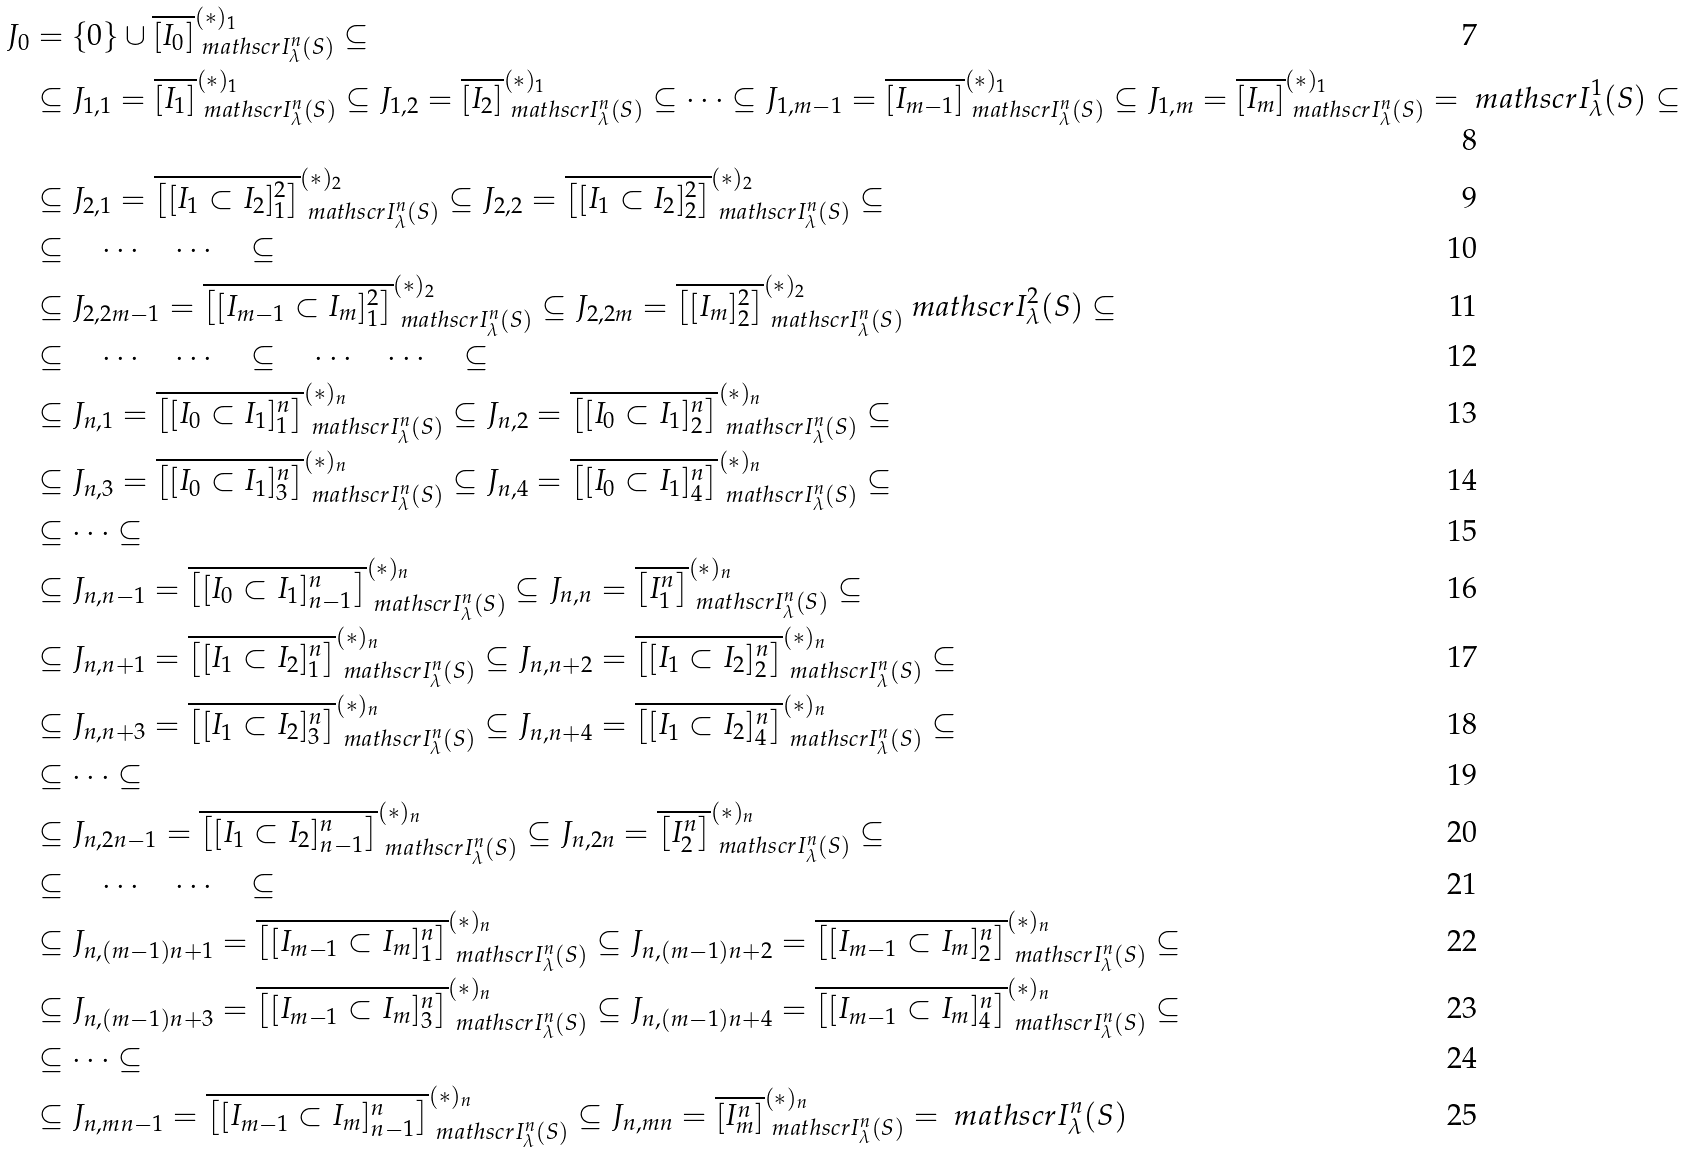<formula> <loc_0><loc_0><loc_500><loc_500>J _ { 0 } & = \{ 0 \} \cup \overline { [ I _ { 0 } ] } ^ { ( \ast ) _ { 1 } } _ { \ m a t h s c r { I } _ { \lambda } ^ { n } ( S ) } \subseteq \\ & \subseteq J _ { 1 , 1 } = \overline { [ I _ { 1 } ] } ^ { ( \ast ) _ { 1 } } _ { \ m a t h s c r { I } _ { \lambda } ^ { n } ( S ) } \subseteq J _ { 1 , 2 } = \overline { [ I _ { 2 } ] } ^ { ( \ast ) _ { 1 } } _ { \ m a t h s c r { I } _ { \lambda } ^ { n } ( S ) } \subseteq \cdots \subseteq J _ { 1 , m - 1 } = \overline { [ I _ { m - 1 } ] } ^ { ( \ast ) _ { 1 } } _ { \ m a t h s c r { I } _ { \lambda } ^ { n } ( S ) } \subseteq J _ { 1 , m } = \overline { [ I _ { m } ] } ^ { ( \ast ) _ { 1 } } _ { \ m a t h s c r { I } _ { \lambda } ^ { n } ( S ) } = \ m a t h s c r { I } _ { \lambda } ^ { 1 } ( S ) \subseteq \\ & \subseteq J _ { 2 , 1 } = \overline { \left [ [ I _ { 1 } \subset I _ { 2 } ] ^ { 2 } _ { 1 } \right ] } ^ { ( \ast ) _ { 2 } } _ { \ m a t h s c r { I } _ { \lambda } ^ { n } ( S ) } \subseteq J _ { 2 , 2 } = \overline { \left [ [ I _ { 1 } \subset I _ { 2 } ] ^ { 2 } _ { 2 } \right ] } ^ { ( \ast ) _ { 2 } } _ { \ m a t h s c r { I } _ { \lambda } ^ { n } ( S ) } \subseteq \\ & \subseteq \quad \cdots \quad \cdots \quad \subseteq \\ & \subseteq J _ { 2 , 2 m - 1 } = \overline { \left [ [ I _ { m - 1 } \subset I _ { m } ] ^ { 2 } _ { 1 } \right ] } ^ { ( \ast ) _ { 2 } } _ { \ m a t h s c r { I } _ { \lambda } ^ { n } ( S ) } \subseteq J _ { 2 , 2 m } = \overline { \left [ [ I _ { m } ] ^ { 2 } _ { 2 } \right ] } ^ { ( \ast ) _ { 2 } } _ { \ m a t h s c r { I } _ { \lambda } ^ { n } ( S ) } \ m a t h s c r { I } _ { \lambda } ^ { 2 } ( S ) \subseteq \\ & \subseteq \quad \cdots \quad \cdots \quad \subseteq \quad \cdots \quad \cdots \quad \subseteq \\ & \subseteq J _ { n , 1 } = \overline { \left [ [ I _ { 0 } \subset I _ { 1 } ] ^ { n } _ { 1 } \right ] } ^ { ( \ast ) _ { n } } _ { \ m a t h s c r { I } _ { \lambda } ^ { n } ( S ) } \subseteq J _ { n , 2 } = \overline { \left [ [ I _ { 0 } \subset I _ { 1 } ] ^ { n } _ { 2 } \right ] } ^ { ( \ast ) _ { n } } _ { \ m a t h s c r { I } _ { \lambda } ^ { n } ( S ) } \subseteq \\ & \subseteq J _ { n , 3 } = \overline { \left [ [ I _ { 0 } \subset I _ { 1 } ] ^ { n } _ { 3 } \right ] } ^ { ( \ast ) _ { n } } _ { \ m a t h s c r { I } _ { \lambda } ^ { n } ( S ) } \subseteq J _ { n , 4 } = \overline { \left [ [ I _ { 0 } \subset I _ { 1 } ] ^ { n } _ { 4 } \right ] } ^ { ( \ast ) _ { n } } _ { \ m a t h s c r { I } _ { \lambda } ^ { n } ( S ) } \subseteq \\ & \subseteq \cdots \subseteq \\ & \subseteq J _ { n , n - 1 } = \overline { \left [ [ I _ { 0 } \subset I _ { 1 } ] ^ { n } _ { n - 1 } \right ] } ^ { ( \ast ) _ { n } } _ { \ m a t h s c r { I } _ { \lambda } ^ { n } ( S ) } \subseteq J _ { n , n } = \overline { \left [ I _ { 1 } ^ { n } \right ] } ^ { ( \ast ) _ { n } } _ { \ m a t h s c r { I } _ { \lambda } ^ { n } ( S ) } \subseteq \\ & \subseteq J _ { n , n + 1 } = \overline { \left [ [ I _ { 1 } \subset I _ { 2 } ] ^ { n } _ { 1 } \right ] } ^ { ( \ast ) _ { n } } _ { \ m a t h s c r { I } _ { \lambda } ^ { n } ( S ) } \subseteq J _ { n , n + 2 } = \overline { \left [ [ I _ { 1 } \subset I _ { 2 } ] ^ { n } _ { 2 } \right ] } ^ { ( \ast ) _ { n } } _ { \ m a t h s c r { I } _ { \lambda } ^ { n } ( S ) } \subseteq \\ & \subseteq J _ { n , n + 3 } = \overline { \left [ [ I _ { 1 } \subset I _ { 2 } ] ^ { n } _ { 3 } \right ] } ^ { ( \ast ) _ { n } } _ { \ m a t h s c r { I } _ { \lambda } ^ { n } ( S ) } \subseteq J _ { n , n + 4 } = \overline { \left [ [ I _ { 1 } \subset I _ { 2 } ] ^ { n } _ { 4 } \right ] } ^ { ( \ast ) _ { n } } _ { \ m a t h s c r { I } _ { \lambda } ^ { n } ( S ) } \subseteq \\ & \subseteq \cdots \subseteq \\ & \subseteq J _ { n , 2 n - 1 } = \overline { \left [ [ I _ { 1 } \subset I _ { 2 } ] ^ { n } _ { n - 1 } \right ] } ^ { ( \ast ) _ { n } } _ { \ m a t h s c r { I } _ { \lambda } ^ { n } ( S ) } \subseteq J _ { n , 2 n } = \overline { \left [ I _ { 2 } ^ { n } \right ] } ^ { ( \ast ) _ { n } } _ { \ m a t h s c r { I } _ { \lambda } ^ { n } ( S ) } \subseteq \\ & \subseteq \quad \cdots \quad \cdots \quad \subseteq \\ & \subseteq J _ { n , ( m - 1 ) n + 1 } = \overline { \left [ [ I _ { m - 1 } \subset I _ { m } ] ^ { n } _ { 1 } \right ] } ^ { ( \ast ) _ { n } } _ { \ m a t h s c r { I } _ { \lambda } ^ { n } ( S ) } \subseteq J _ { n , ( m - 1 ) n + 2 } = \overline { \left [ [ I _ { m - 1 } \subset I _ { m } ] ^ { n } _ { 2 } \right ] } ^ { ( \ast ) _ { n } } _ { \ m a t h s c r { I } _ { \lambda } ^ { n } ( S ) } \subseteq \\ & \subseteq J _ { n , ( m - 1 ) n + 3 } = \overline { \left [ [ I _ { m - 1 } \subset I _ { m } ] ^ { n } _ { 3 } \right ] } ^ { ( \ast ) _ { n } } _ { \ m a t h s c r { I } _ { \lambda } ^ { n } ( S ) } \subseteq J _ { n , ( m - 1 ) n + 4 } = \overline { \left [ [ I _ { m - 1 } \subset I _ { m } ] ^ { n } _ { 4 } \right ] } ^ { ( \ast ) _ { n } } _ { \ m a t h s c r { I } _ { \lambda } ^ { n } ( S ) } \subseteq \\ & \subseteq \cdots \subseteq \\ & \subseteq J _ { n , m n - 1 } = \overline { \left [ [ I _ { m - 1 } \subset I _ { m } ] ^ { n } _ { n - 1 } \right ] } ^ { ( \ast ) _ { n } } _ { \ m a t h s c r { I } _ { \lambda } ^ { n } ( S ) } \subseteq J _ { n , m n } = \overline { \left [ I _ { m } ^ { n } \right ] } ^ { ( \ast ) _ { n } } _ { \ m a t h s c r { I } _ { \lambda } ^ { n } ( S ) } = \ m a t h s c r { I } _ { \lambda } ^ { n } ( S )</formula> 